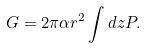<formula> <loc_0><loc_0><loc_500><loc_500>G = 2 \pi \alpha r ^ { 2 } \int d z P .</formula> 